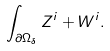Convert formula to latex. <formula><loc_0><loc_0><loc_500><loc_500>\int _ { \partial \Omega _ { \delta } } Z ^ { i } + W ^ { i } .</formula> 